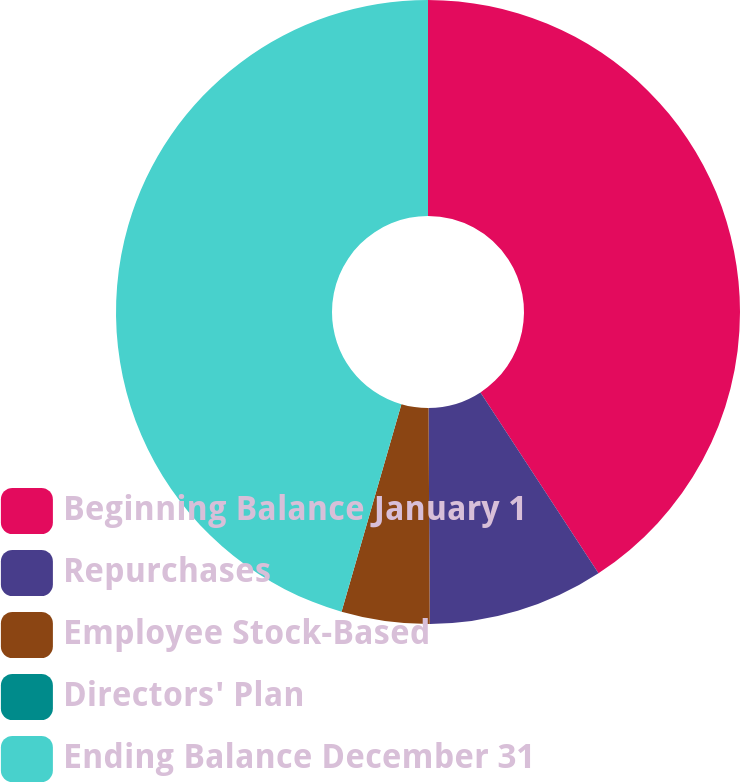Convert chart. <chart><loc_0><loc_0><loc_500><loc_500><pie_chart><fcel>Beginning Balance January 1<fcel>Repurchases<fcel>Employee Stock-Based<fcel>Directors' Plan<fcel>Ending Balance December 31<nl><fcel>40.8%<fcel>9.11%<fcel>4.56%<fcel>0.0%<fcel>45.53%<nl></chart> 